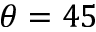Convert formula to latex. <formula><loc_0><loc_0><loc_500><loc_500>\theta = 4 5</formula> 